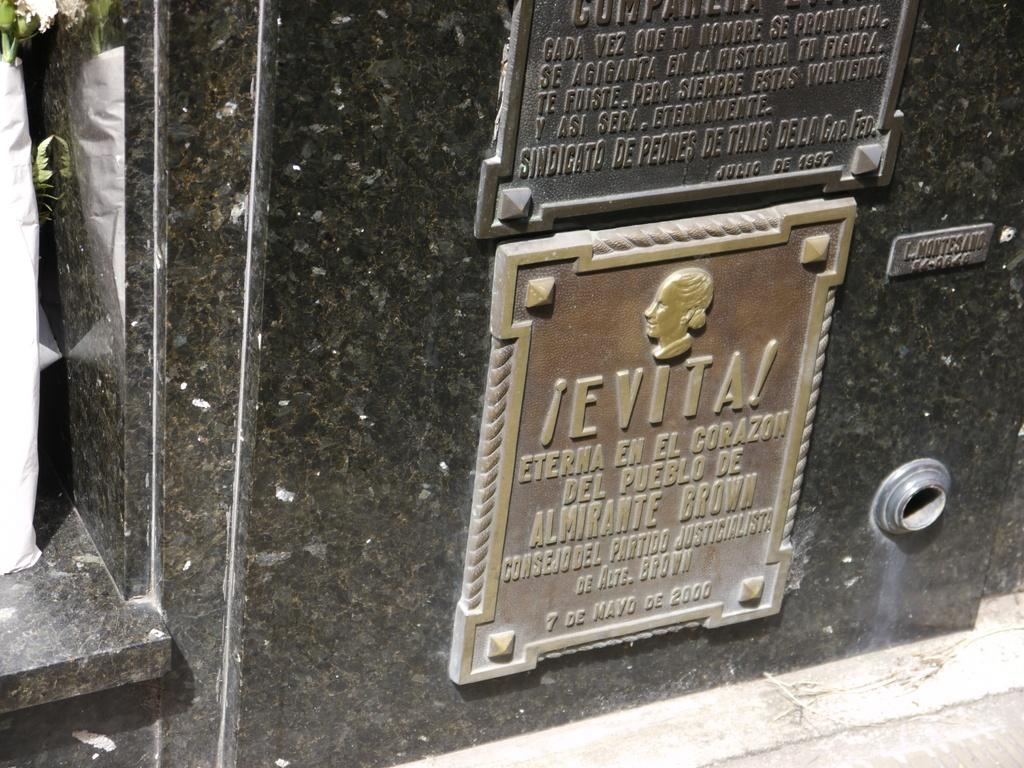What is the main subject of the image? There is a memorial in the image. What else can be seen in the image besides the memorial? There is a board and a tree in the image. Can you describe the lighting in the image? The image was likely taken during the day, as there is sufficient light to see the details. What type of country is depicted in the image? The image does not depict a country; it features a memorial, a board, and a tree. Can you tell me how many vases are present in the image? There are no vases present in the image. 